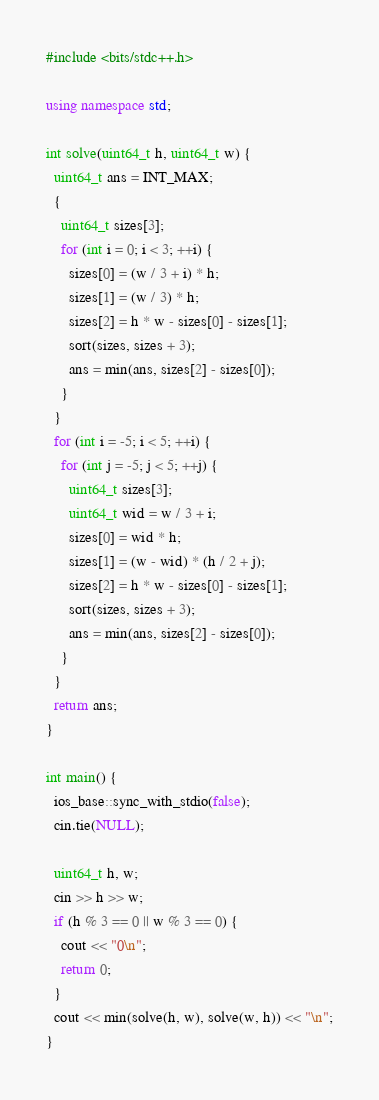Convert code to text. <code><loc_0><loc_0><loc_500><loc_500><_C++_>#include <bits/stdc++.h>

using namespace std;

int solve(uint64_t h, uint64_t w) {
  uint64_t ans = INT_MAX;
  {
    uint64_t sizes[3];
    for (int i = 0; i < 3; ++i) {
      sizes[0] = (w / 3 + i) * h;
      sizes[1] = (w / 3) * h;
      sizes[2] = h * w - sizes[0] - sizes[1];
      sort(sizes, sizes + 3);
      ans = min(ans, sizes[2] - sizes[0]);
    }
  }
  for (int i = -5; i < 5; ++i) {
    for (int j = -5; j < 5; ++j) {
      uint64_t sizes[3];
      uint64_t wid = w / 3 + i;
      sizes[0] = wid * h;
      sizes[1] = (w - wid) * (h / 2 + j);
      sizes[2] = h * w - sizes[0] - sizes[1];
      sort(sizes, sizes + 3);
      ans = min(ans, sizes[2] - sizes[0]);
    }
  }
  return ans;
}

int main() {
  ios_base::sync_with_stdio(false);
  cin.tie(NULL);

  uint64_t h, w;
  cin >> h >> w;
  if (h % 3 == 0 || w % 3 == 0) {
    cout << "0\n";
    return 0;
  }
  cout << min(solve(h, w), solve(w, h)) << "\n";
}
</code> 